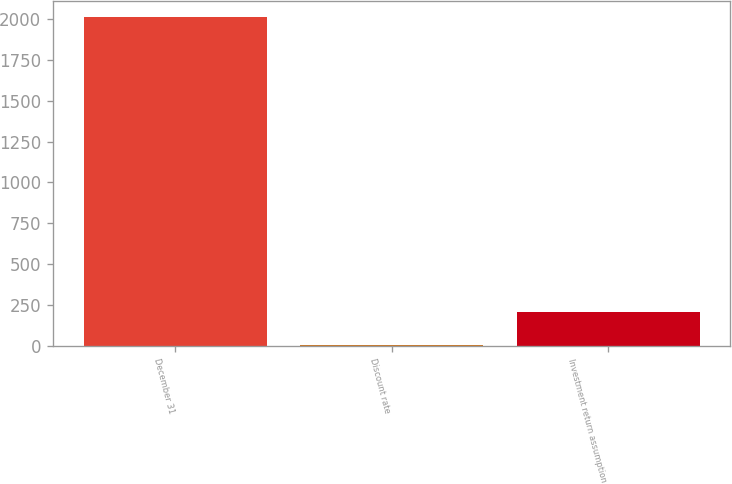Convert chart to OTSL. <chart><loc_0><loc_0><loc_500><loc_500><bar_chart><fcel>December 31<fcel>Discount rate<fcel>Investment return assumption<nl><fcel>2013<fcel>4.16<fcel>205.04<nl></chart> 